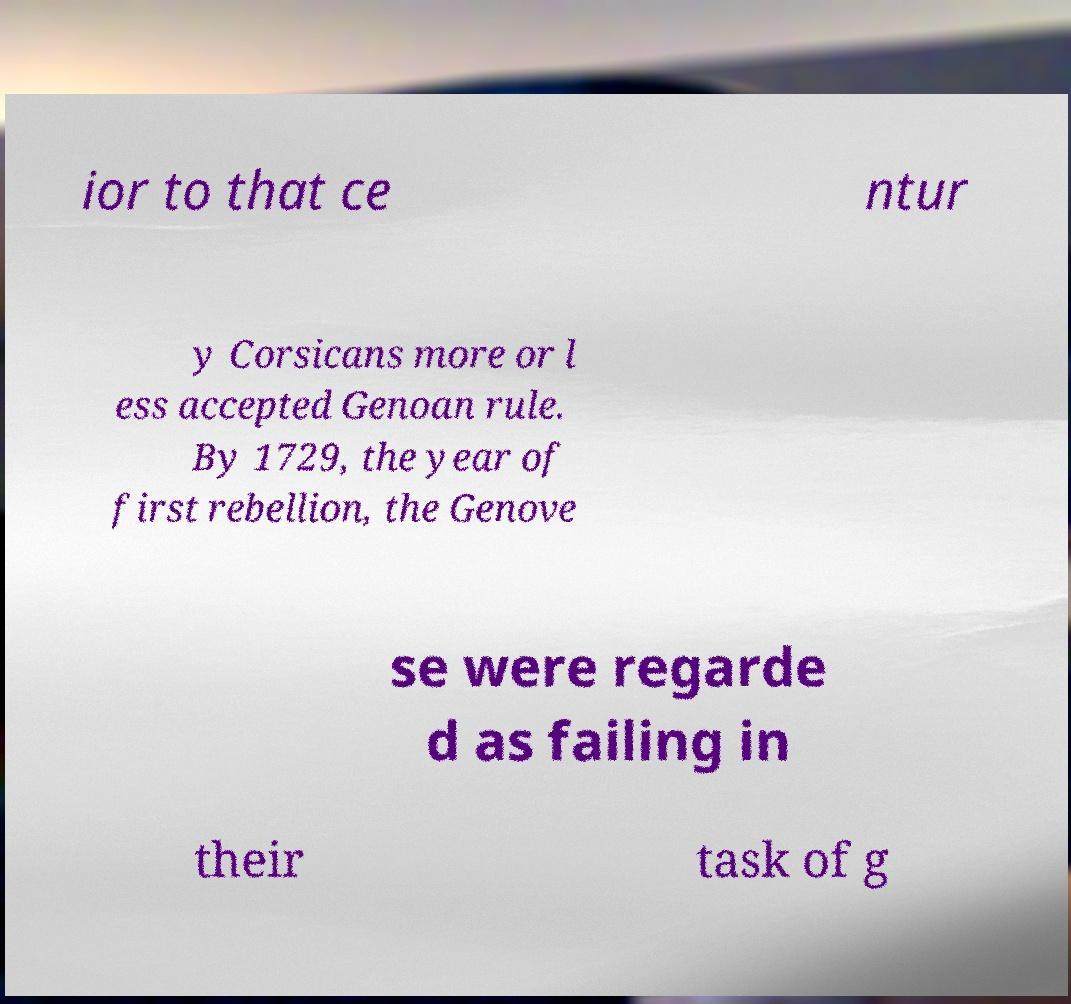Can you read and provide the text displayed in the image?This photo seems to have some interesting text. Can you extract and type it out for me? ior to that ce ntur y Corsicans more or l ess accepted Genoan rule. By 1729, the year of first rebellion, the Genove se were regarde d as failing in their task of g 